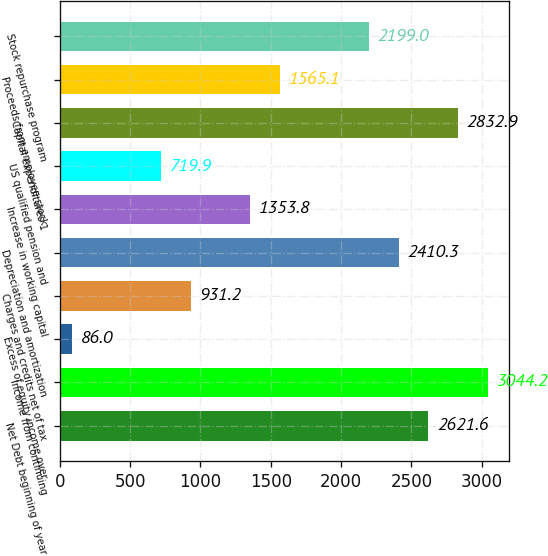Convert chart to OTSL. <chart><loc_0><loc_0><loc_500><loc_500><bar_chart><fcel>Net Debt beginning of year<fcel>Income from continuing<fcel>Excess of equity income over<fcel>Charges and credits net of tax<fcel>Depreciation and amortization<fcel>Increase in working capital<fcel>US qualified pension and<fcel>Capital expenditures 1<fcel>Proceeds from employee stock<fcel>Stock repurchase program<nl><fcel>2621.6<fcel>3044.2<fcel>86<fcel>931.2<fcel>2410.3<fcel>1353.8<fcel>719.9<fcel>2832.9<fcel>1565.1<fcel>2199<nl></chart> 